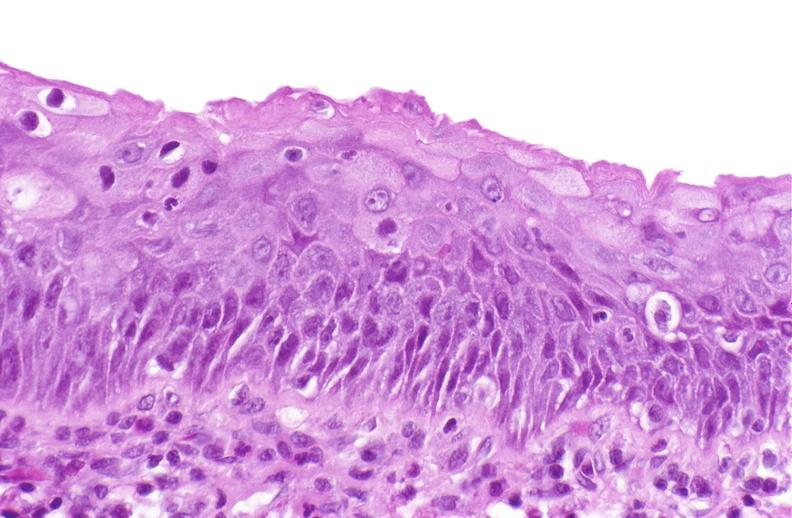s urinary present?
Answer the question using a single word or phrase. Yes 